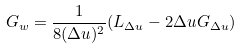Convert formula to latex. <formula><loc_0><loc_0><loc_500><loc_500>G _ { w } = \frac { 1 } { 8 ( \Delta u ) ^ { 2 } } ( L _ { \Delta u } - 2 \Delta u G _ { \Delta u } )</formula> 